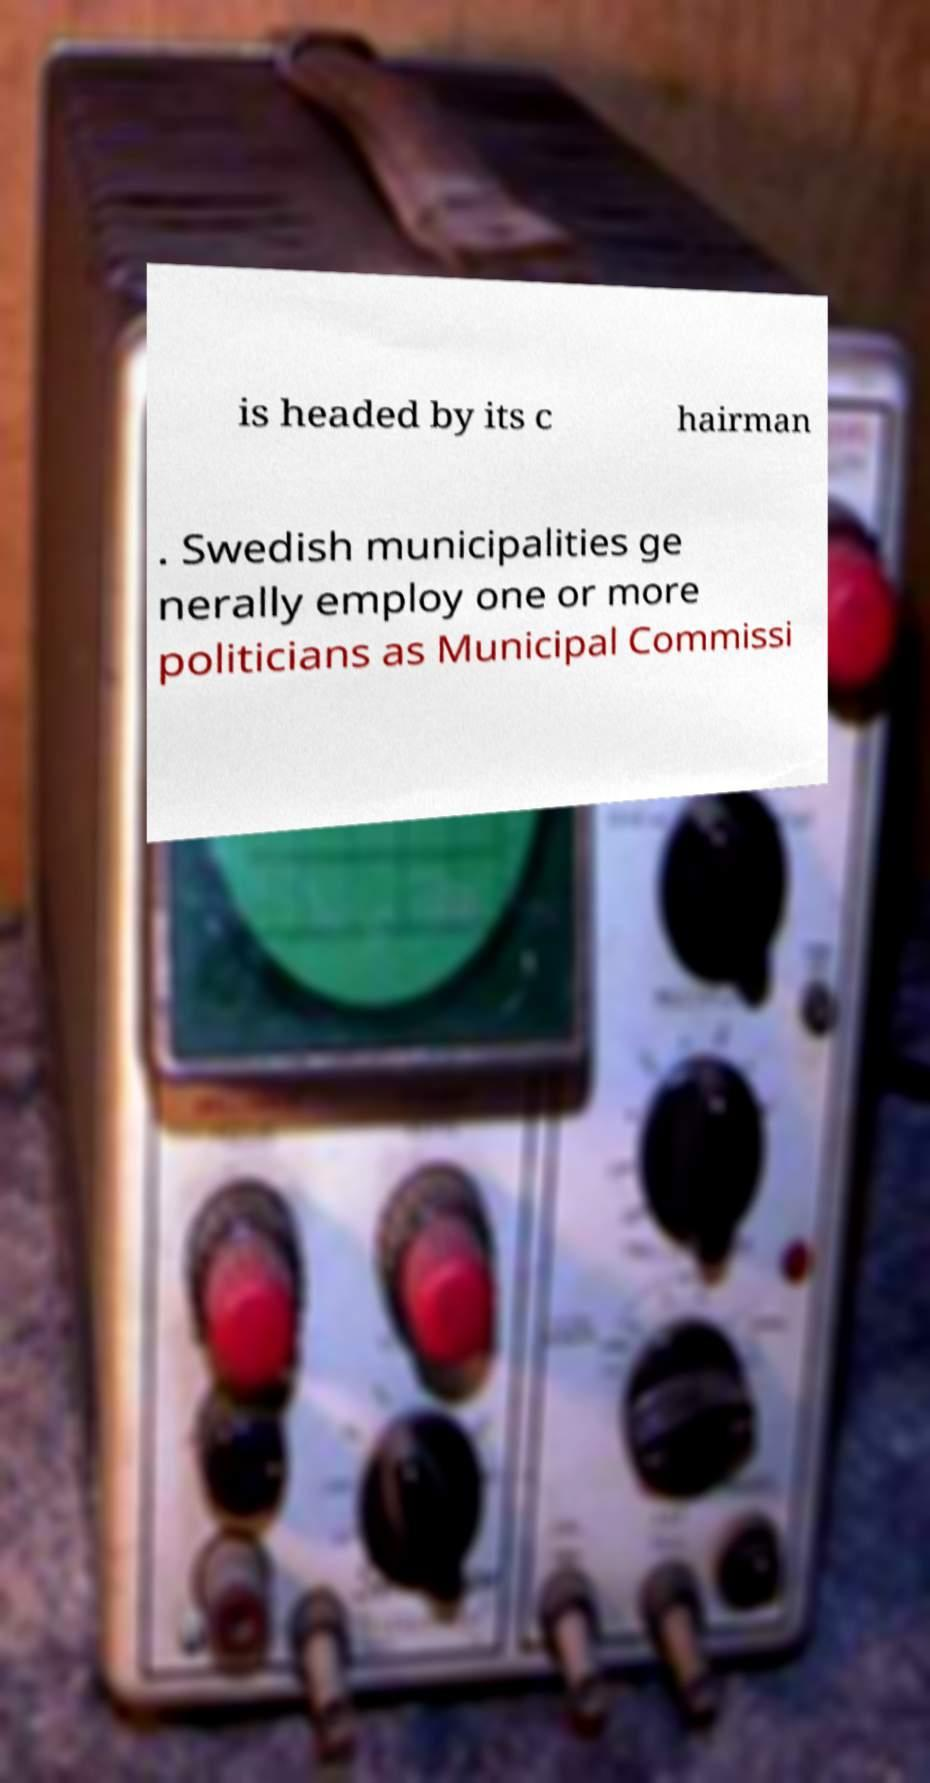What messages or text are displayed in this image? I need them in a readable, typed format. is headed by its c hairman . Swedish municipalities ge nerally employ one or more politicians as Municipal Commissi 